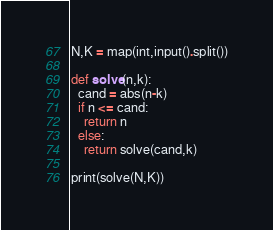<code> <loc_0><loc_0><loc_500><loc_500><_Python_>N,K = map(int,input().split())

def solve(n,k):
  cand = abs(n-k)
  if n <= cand:
    return n
  else:
    return solve(cand,k)

print(solve(N,K))</code> 